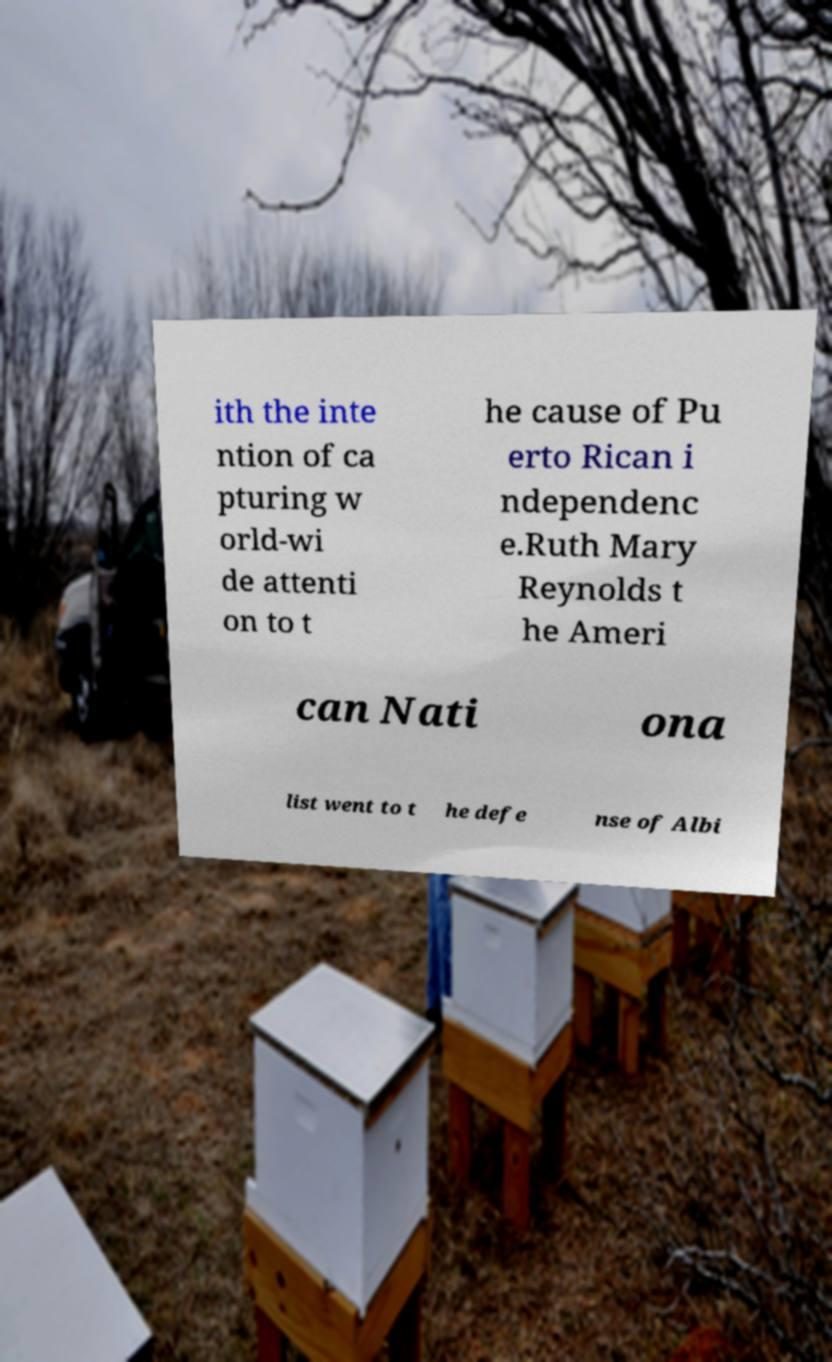What messages or text are displayed in this image? I need them in a readable, typed format. ith the inte ntion of ca pturing w orld-wi de attenti on to t he cause of Pu erto Rican i ndependenc e.Ruth Mary Reynolds t he Ameri can Nati ona list went to t he defe nse of Albi 